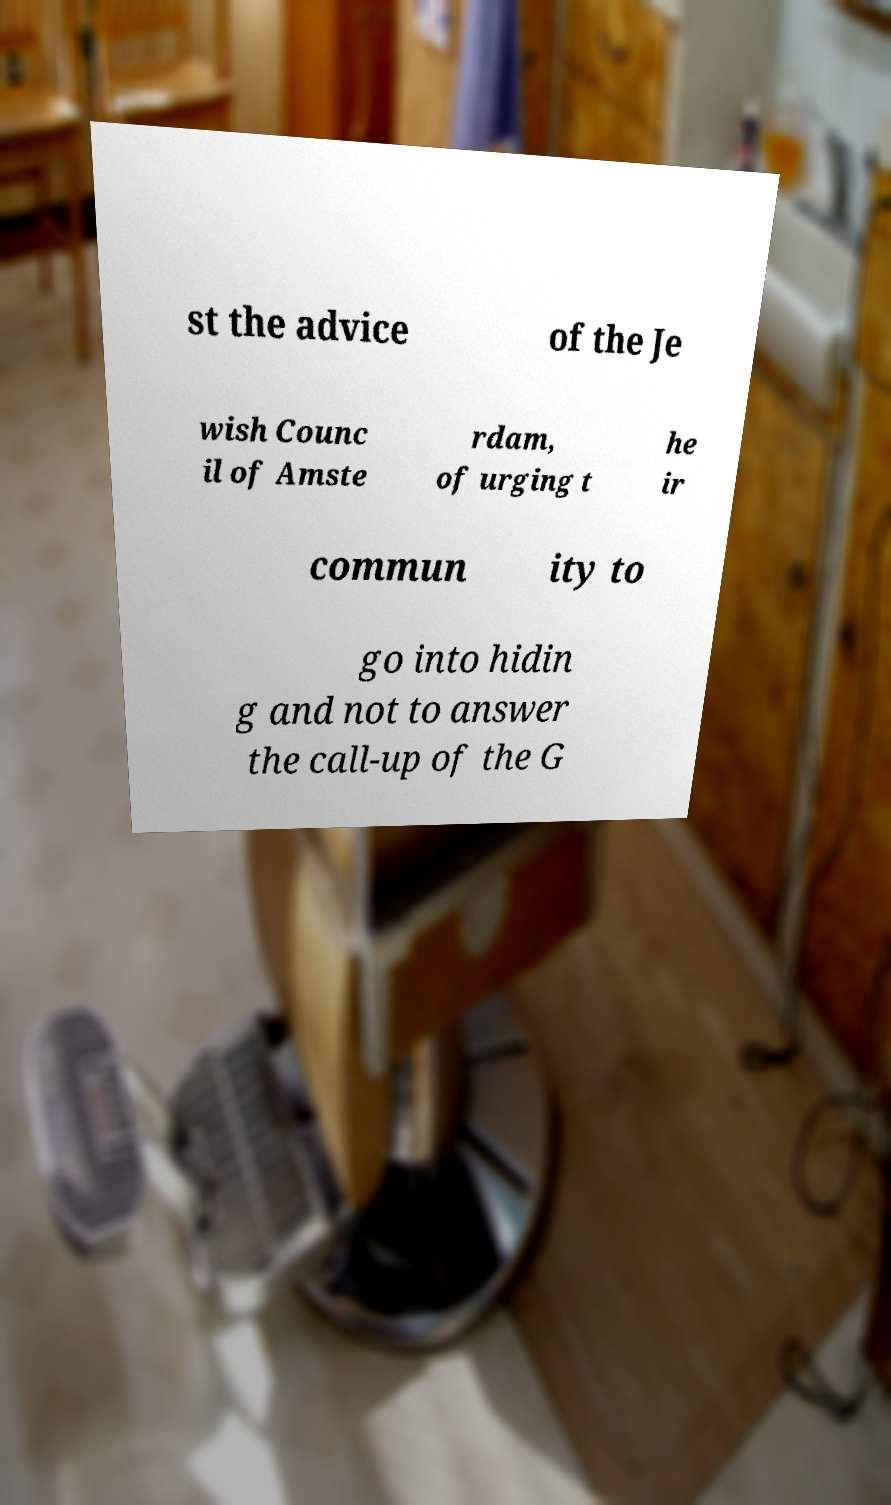Can you read and provide the text displayed in the image?This photo seems to have some interesting text. Can you extract and type it out for me? st the advice of the Je wish Counc il of Amste rdam, of urging t he ir commun ity to go into hidin g and not to answer the call-up of the G 